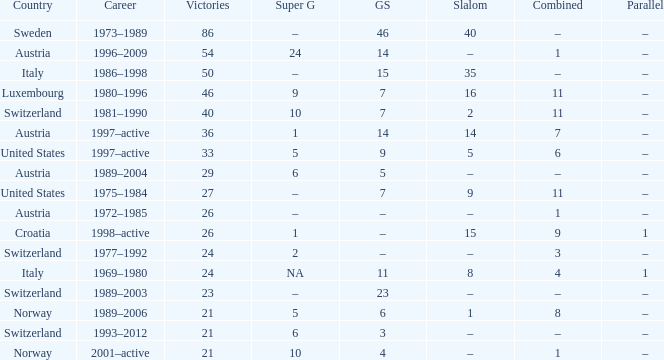What Career has a Parallel of –, a Combined of –, and a Giant Slalom of 5? 1989–2004. 